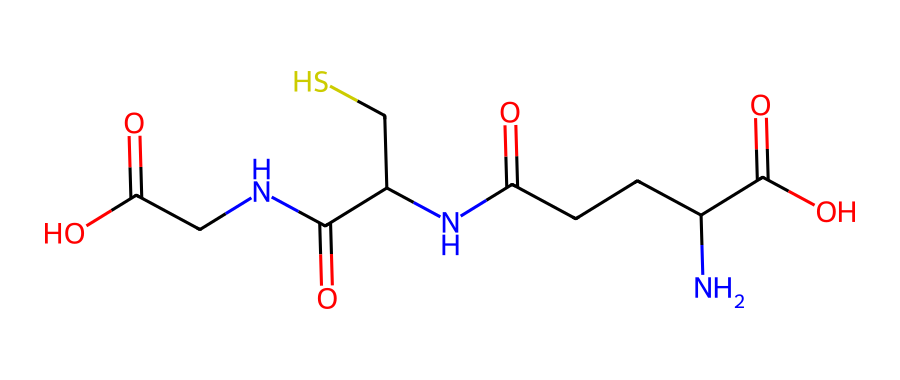What is the total number of carbon atoms in glutathione? By analyzing the provided SMILES representation, we can count the 'C' symbols, which indicate carbon atoms. There are a total of four 'C' symbols in the backbone, and additional carbon atoms are part of functional groups. Counting all gives a total of 10 carbon atoms.
Answer: 10 How many amino groups (NH) are present in glutathione's structure? In the SMILES notation, the presence of 'N' represents nitrogen atoms that form amino groups. There are three 'N' atoms indicated in the structure, suggesting the presence of three amino groups.
Answer: 3 What is the main functional group present in glutathione? By examining the structure, it’s clear that the thiol group (-SH) is represented in the chemical, which is crucial for its antioxidant properties. Therefore, the main functional group is the thiol group.
Answer: thiol group What is the net charge of glutathione at physiological pH? At physiological pH, the carboxylic acid groups are typically deprotonated and negatively charged (-COO−), while the amino groups are protonated (+NH3). Given the number of each type of group, glutathione has a net charge of -1 at physiological pH.
Answer: -1 Which part of glutathione's structure is primarily responsible for its antioxidant properties? The thiol group (-SH) present in glutathione is essential for its ability to donate electrons to free radicals, thus neutralizing oxidative stress. This is the part of the structure that imparts its antioxidant properties.
Answer: thiol group What type of reaction typically involves the functional groups found in glutathione? Glutathione is involved in reduction-oxidation (redox) reactions, where its thiol group is crucial for the reduction of oxidized molecules, indicating it primarily participates in redox reactions.
Answer: redox reactions 